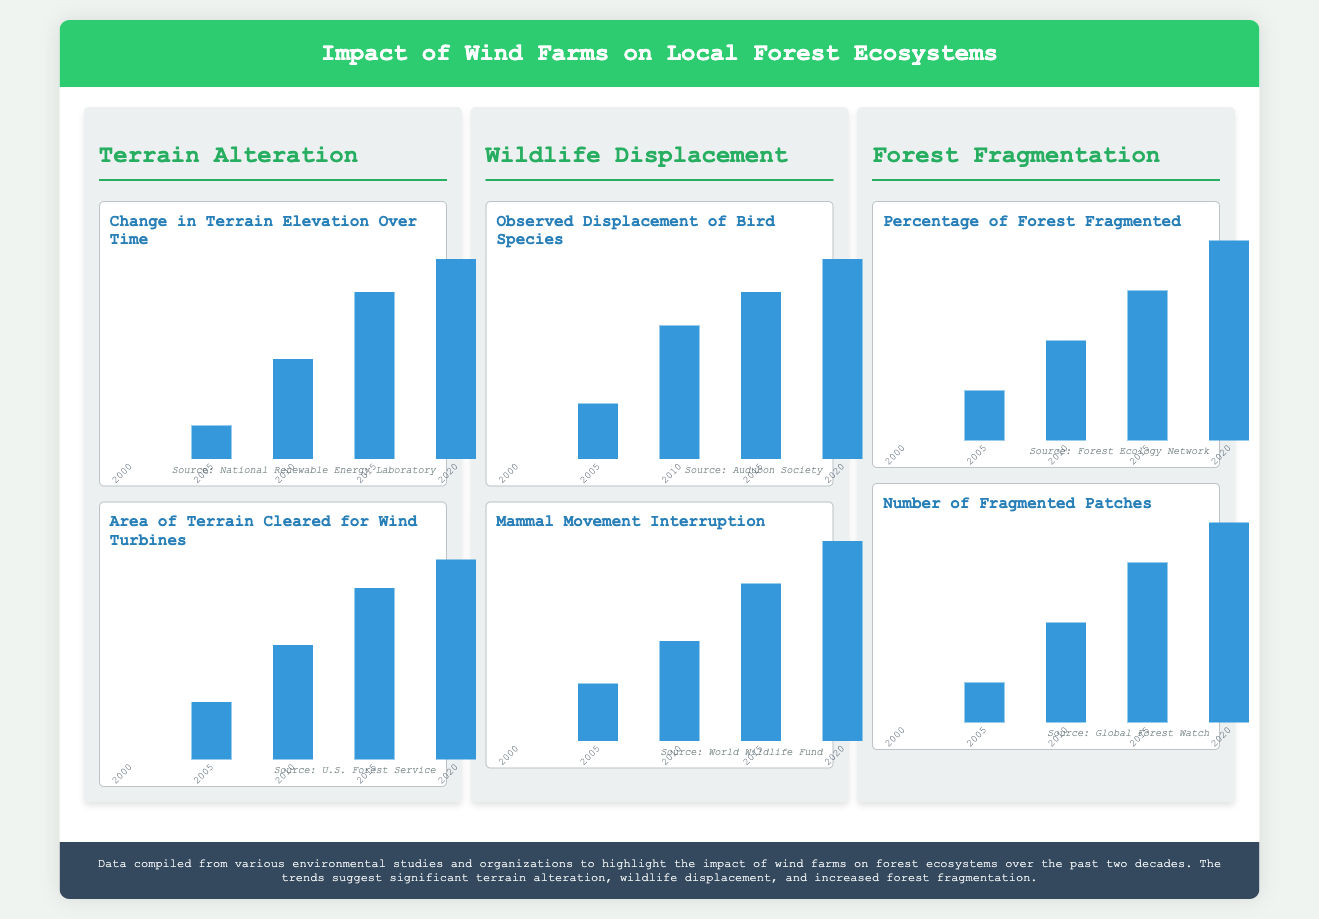What is the height of terrain alteration in 2015? The height of terrain alteration in 2015 is shown as 83.33% in the chart.
Answer: 83.33% What is the observed displacement of bird species in 2020? The observed displacement of bird species in 2020 is represented as 100% in the chart.
Answer: 100% What year had the lowest area of terrain cleared for wind turbines? The chart shows that in 2000, the lowest area of terrain cleared was at 0%.
Answer: 2000 Which organization published the data on mammal movement interruption? The data on mammal movement interruption is sourced from the World Wildlife Fund.
Answer: World Wildlife Fund What was the percentage of forest fragmented in 2010? The percentage of forest fragmented in 2010 is represented as 50% in the chart.
Answer: 50% In which year did the number of fragmented patches reach 80%? The number of fragmented patches reached 80% in 2015, as shown in the data.
Answer: 2015 How much of the bird species were displaced by 2015? The chart indicates that 83.33% of bird species were displaced by 2015.
Answer: 83.33% Which data source is referenced for terrain alteration? The data source for terrain alteration is the National Renewable Energy Laboratory.
Answer: National Renewable Energy Laboratory What is the trend in the percentage of forest fragmented from 2000 to 2020? The trend shows an increasing percentage of forest fragmentation over the years from 0% to 100%.
Answer: Increasing 